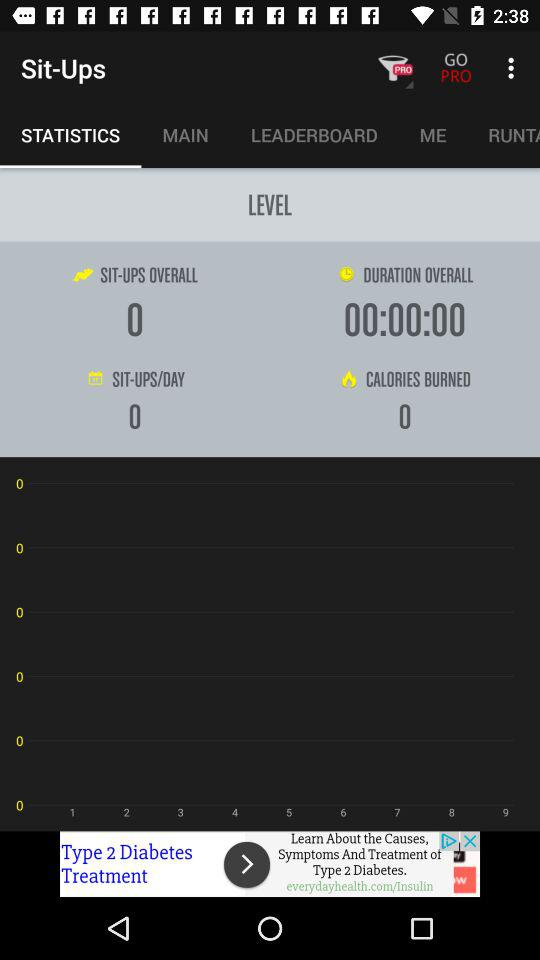What is the overall duration of "Sit-Ups"? The overall duration is 00:00:00. 